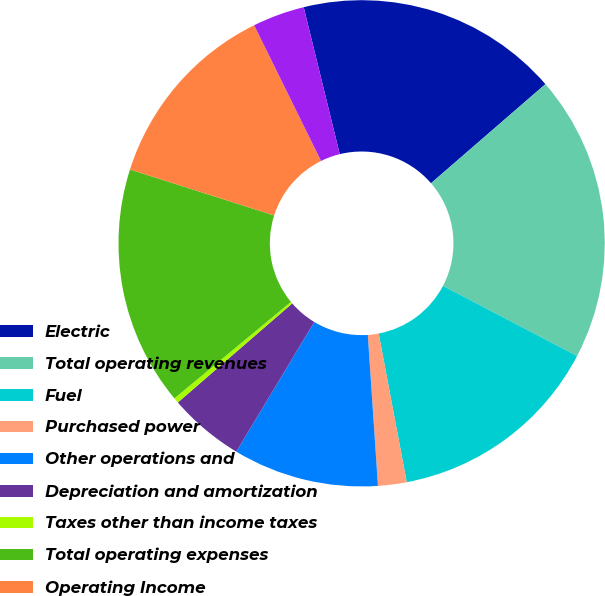<chart> <loc_0><loc_0><loc_500><loc_500><pie_chart><fcel>Electric<fcel>Total operating revenues<fcel>Fuel<fcel>Purchased power<fcel>Other operations and<fcel>Depreciation and amortization<fcel>Taxes other than income taxes<fcel>Total operating expenses<fcel>Operating Income<fcel>Interest Charges<nl><fcel>17.47%<fcel>19.03%<fcel>14.36%<fcel>1.9%<fcel>9.69%<fcel>5.02%<fcel>0.35%<fcel>15.92%<fcel>12.8%<fcel>3.46%<nl></chart> 